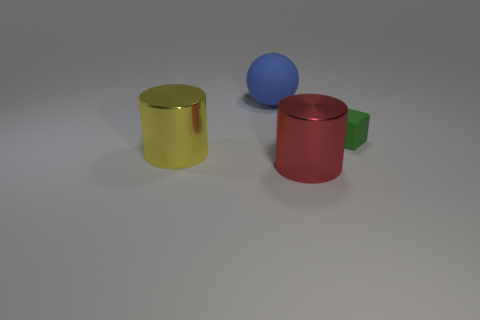Add 3 matte objects. How many objects exist? 7 Subtract all blocks. How many objects are left? 3 Subtract 0 purple blocks. How many objects are left? 4 Subtract all red rubber cylinders. Subtract all spheres. How many objects are left? 3 Add 3 large balls. How many large balls are left? 4 Add 3 big spheres. How many big spheres exist? 4 